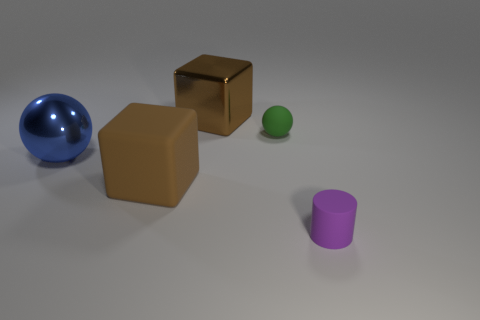Is there a green object made of the same material as the big blue object?
Offer a terse response. No. Do the brown cube behind the green thing and the purple thing have the same material?
Ensure brevity in your answer.  No. Is the number of blue objects that are behind the tiny purple thing greater than the number of cylinders behind the blue metallic thing?
Ensure brevity in your answer.  Yes. What is the color of the sphere that is the same size as the purple thing?
Offer a terse response. Green. Are there any big matte blocks that have the same color as the big rubber thing?
Provide a succinct answer. No. There is a big matte cube that is left of the small sphere; is it the same color as the large cube behind the large matte cube?
Provide a short and direct response. Yes. There is a large cube behind the blue metal object; what is it made of?
Ensure brevity in your answer.  Metal. What color is the tiny thing that is the same material as the green sphere?
Ensure brevity in your answer.  Purple. How many brown metal cubes have the same size as the purple cylinder?
Make the answer very short. 0. There is a thing that is to the right of the rubber ball; is its size the same as the matte sphere?
Your answer should be very brief. Yes. 